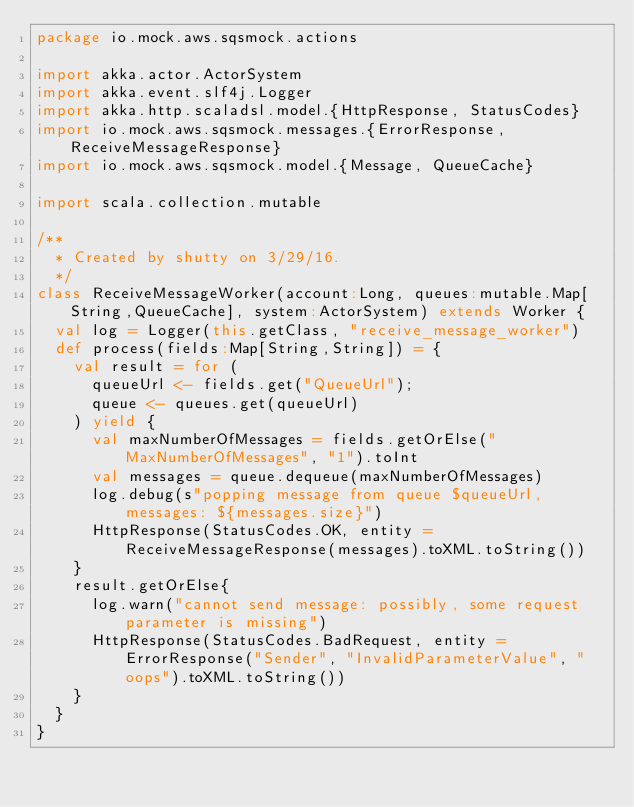Convert code to text. <code><loc_0><loc_0><loc_500><loc_500><_Scala_>package io.mock.aws.sqsmock.actions

import akka.actor.ActorSystem
import akka.event.slf4j.Logger
import akka.http.scaladsl.model.{HttpResponse, StatusCodes}
import io.mock.aws.sqsmock.messages.{ErrorResponse, ReceiveMessageResponse}
import io.mock.aws.sqsmock.model.{Message, QueueCache}

import scala.collection.mutable

/**
  * Created by shutty on 3/29/16.
  */
class ReceiveMessageWorker(account:Long, queues:mutable.Map[String,QueueCache], system:ActorSystem) extends Worker {
  val log = Logger(this.getClass, "receive_message_worker")
  def process(fields:Map[String,String]) = {
    val result = for (
      queueUrl <- fields.get("QueueUrl");
      queue <- queues.get(queueUrl)
    ) yield {
      val maxNumberOfMessages = fields.getOrElse("MaxNumberOfMessages", "1").toInt
      val messages = queue.dequeue(maxNumberOfMessages)
      log.debug(s"popping message from queue $queueUrl, messages: ${messages.size}")
      HttpResponse(StatusCodes.OK, entity = ReceiveMessageResponse(messages).toXML.toString())
    }
    result.getOrElse{
      log.warn("cannot send message: possibly, some request parameter is missing")
      HttpResponse(StatusCodes.BadRequest, entity = ErrorResponse("Sender", "InvalidParameterValue", "oops").toXML.toString())
    }
  }
}
</code> 